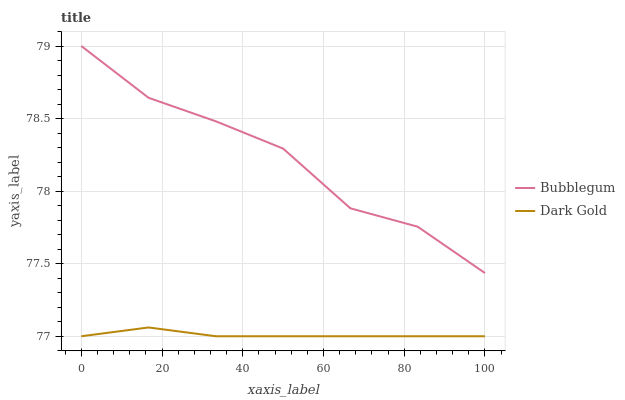Does Dark Gold have the minimum area under the curve?
Answer yes or no. Yes. Does Bubblegum have the maximum area under the curve?
Answer yes or no. Yes. Does Dark Gold have the maximum area under the curve?
Answer yes or no. No. Is Dark Gold the smoothest?
Answer yes or no. Yes. Is Bubblegum the roughest?
Answer yes or no. Yes. Is Dark Gold the roughest?
Answer yes or no. No. Does Dark Gold have the lowest value?
Answer yes or no. Yes. Does Bubblegum have the highest value?
Answer yes or no. Yes. Does Dark Gold have the highest value?
Answer yes or no. No. Is Dark Gold less than Bubblegum?
Answer yes or no. Yes. Is Bubblegum greater than Dark Gold?
Answer yes or no. Yes. Does Dark Gold intersect Bubblegum?
Answer yes or no. No. 